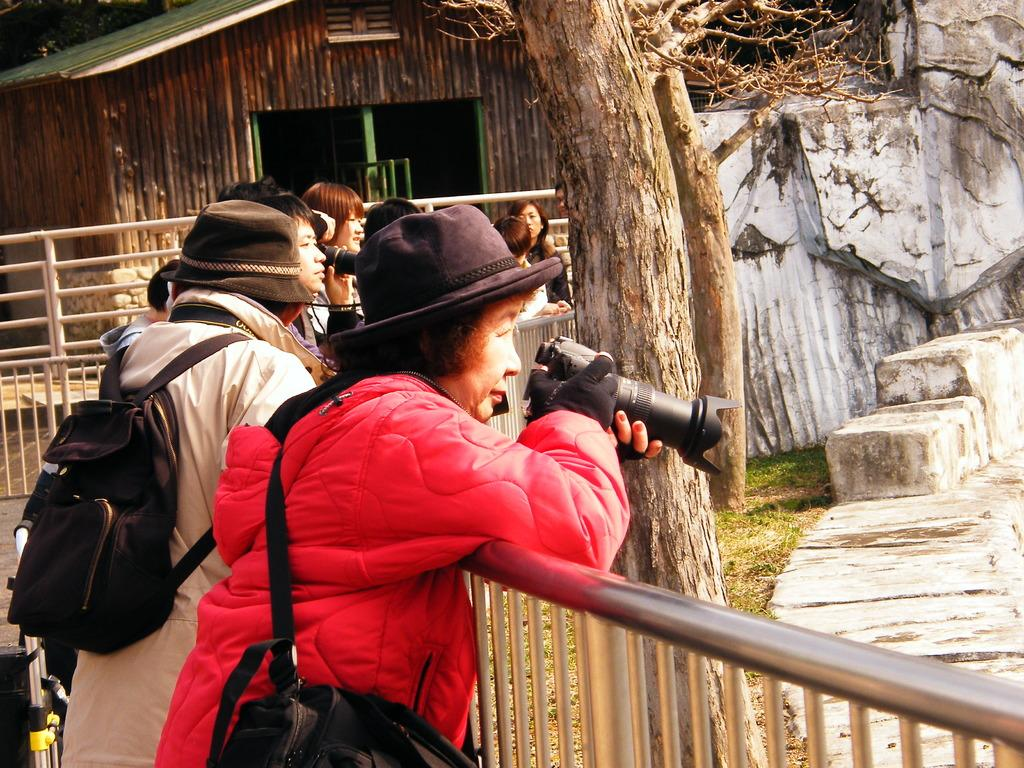How many people are in the image? There are people in the image, but the exact number is not specified. What are the people doing in the image? The people are leaning on a railing and taking pictures with cameras. What can be seen in the background of the image? There are trees, rocks, a house, and a railing in the background of the image. What type of chin is visible on the people in the image? There is no mention of anyone's chin in the image, so it cannot be determined. Are any of the people wearing a cast in the image? There is no mention of anyone wearing a cast in the image, so it cannot be determined. 